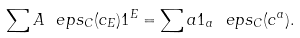Convert formula to latex. <formula><loc_0><loc_0><loc_500><loc_500>\sum A \ e p s _ { C } ( c _ { E } ) 1 ^ { E } = \sum a 1 _ { a } \ e p s _ { C } ( c ^ { a } ) .</formula> 